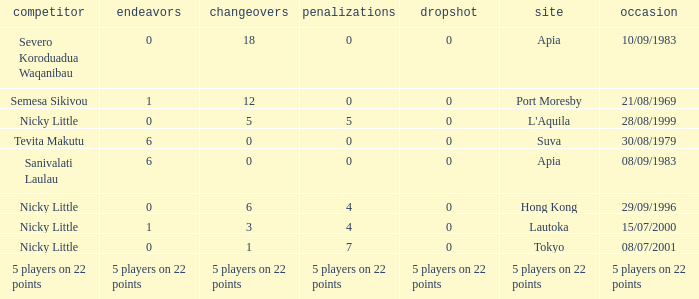How many drops did Nicky Little have in Hong Kong? 0.0. 